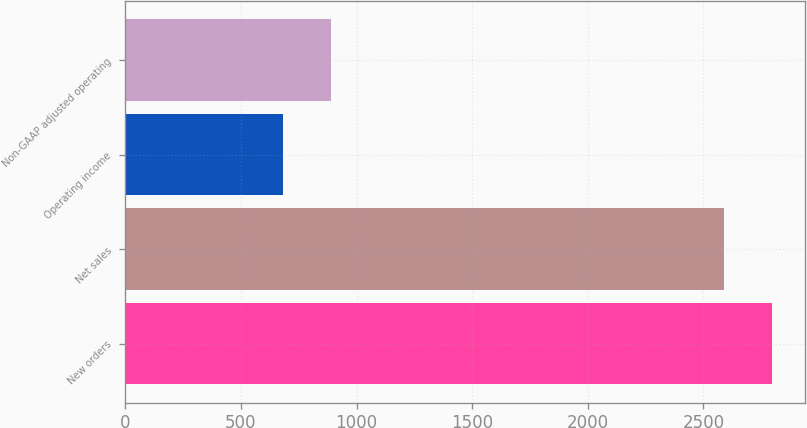<chart> <loc_0><loc_0><loc_500><loc_500><bar_chart><fcel>New orders<fcel>Net sales<fcel>Operating income<fcel>Non-GAAP adjusted operating<nl><fcel>2798.3<fcel>2589<fcel>682<fcel>891.3<nl></chart> 